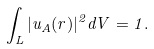Convert formula to latex. <formula><loc_0><loc_0><loc_500><loc_500>\int _ { L } | u _ { A } ( r ) | ^ { 2 } d V = 1 .</formula> 